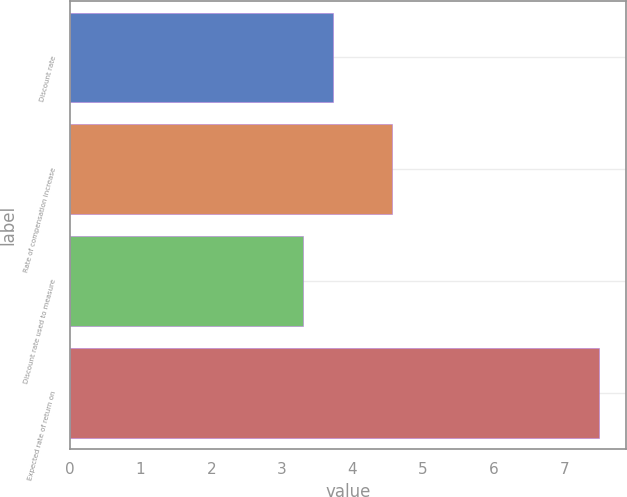Convert chart to OTSL. <chart><loc_0><loc_0><loc_500><loc_500><bar_chart><fcel>Discount rate<fcel>Rate of compensation increase<fcel>Discount rate used to measure<fcel>Expected rate of return on<nl><fcel>3.72<fcel>4.56<fcel>3.3<fcel>7.5<nl></chart> 